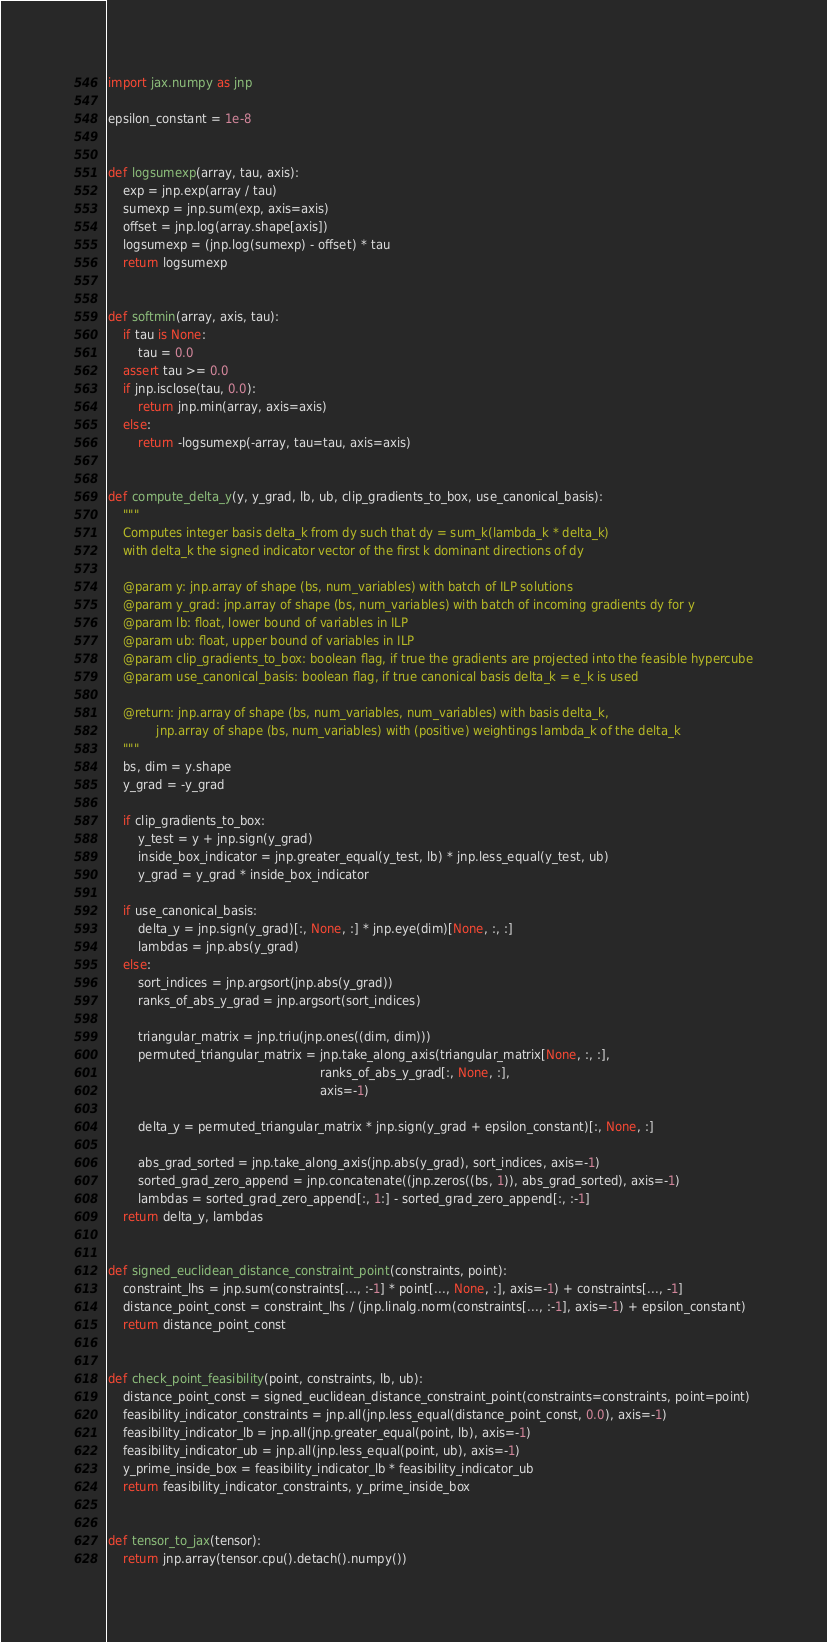Convert code to text. <code><loc_0><loc_0><loc_500><loc_500><_Python_>import jax.numpy as jnp

epsilon_constant = 1e-8


def logsumexp(array, tau, axis):
    exp = jnp.exp(array / tau)
    sumexp = jnp.sum(exp, axis=axis)
    offset = jnp.log(array.shape[axis])
    logsumexp = (jnp.log(sumexp) - offset) * tau
    return logsumexp


def softmin(array, axis, tau):
    if tau is None:
        tau = 0.0
    assert tau >= 0.0
    if jnp.isclose(tau, 0.0):
        return jnp.min(array, axis=axis)
    else:
        return -logsumexp(-array, tau=tau, axis=axis)


def compute_delta_y(y, y_grad, lb, ub, clip_gradients_to_box, use_canonical_basis):
    """
    Computes integer basis delta_k from dy such that dy = sum_k(lambda_k * delta_k)
    with delta_k the signed indicator vector of the first k dominant directions of dy

    @param y: jnp.array of shape (bs, num_variables) with batch of ILP solutions
    @param y_grad: jnp.array of shape (bs, num_variables) with batch of incoming gradients dy for y
    @param lb: float, lower bound of variables in ILP
    @param ub: float, upper bound of variables in ILP
    @param clip_gradients_to_box: boolean flag, if true the gradients are projected into the feasible hypercube
    @param use_canonical_basis: boolean flag, if true canonical basis delta_k = e_k is used

    @return: jnp.array of shape (bs, num_variables, num_variables) with basis delta_k,
             jnp.array of shape (bs, num_variables) with (positive) weightings lambda_k of the delta_k
    """
    bs, dim = y.shape
    y_grad = -y_grad

    if clip_gradients_to_box:
        y_test = y + jnp.sign(y_grad)
        inside_box_indicator = jnp.greater_equal(y_test, lb) * jnp.less_equal(y_test, ub)
        y_grad = y_grad * inside_box_indicator

    if use_canonical_basis:
        delta_y = jnp.sign(y_grad)[:, None, :] * jnp.eye(dim)[None, :, :]
        lambdas = jnp.abs(y_grad)
    else:
        sort_indices = jnp.argsort(jnp.abs(y_grad))
        ranks_of_abs_y_grad = jnp.argsort(sort_indices)

        triangular_matrix = jnp.triu(jnp.ones((dim, dim)))
        permuted_triangular_matrix = jnp.take_along_axis(triangular_matrix[None, :, :],
                                                         ranks_of_abs_y_grad[:, None, :],
                                                         axis=-1)

        delta_y = permuted_triangular_matrix * jnp.sign(y_grad + epsilon_constant)[:, None, :]

        abs_grad_sorted = jnp.take_along_axis(jnp.abs(y_grad), sort_indices, axis=-1)
        sorted_grad_zero_append = jnp.concatenate((jnp.zeros((bs, 1)), abs_grad_sorted), axis=-1)
        lambdas = sorted_grad_zero_append[:, 1:] - sorted_grad_zero_append[:, :-1]
    return delta_y, lambdas


def signed_euclidean_distance_constraint_point(constraints, point):
    constraint_lhs = jnp.sum(constraints[..., :-1] * point[..., None, :], axis=-1) + constraints[..., -1]
    distance_point_const = constraint_lhs / (jnp.linalg.norm(constraints[..., :-1], axis=-1) + epsilon_constant)
    return distance_point_const


def check_point_feasibility(point, constraints, lb, ub):
    distance_point_const = signed_euclidean_distance_constraint_point(constraints=constraints, point=point)
    feasibility_indicator_constraints = jnp.all(jnp.less_equal(distance_point_const, 0.0), axis=-1)
    feasibility_indicator_lb = jnp.all(jnp.greater_equal(point, lb), axis=-1)
    feasibility_indicator_ub = jnp.all(jnp.less_equal(point, ub), axis=-1)
    y_prime_inside_box = feasibility_indicator_lb * feasibility_indicator_ub
    return feasibility_indicator_constraints, y_prime_inside_box


def tensor_to_jax(tensor):
    return jnp.array(tensor.cpu().detach().numpy())
</code> 